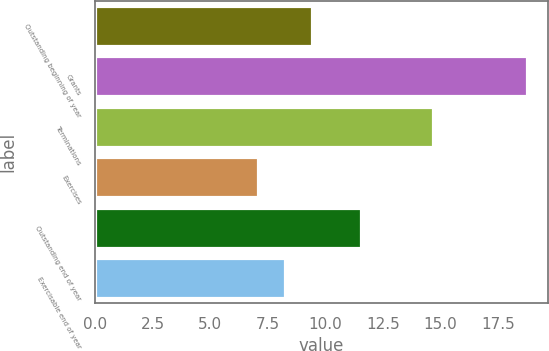<chart> <loc_0><loc_0><loc_500><loc_500><bar_chart><fcel>Outstanding beginning of year<fcel>Grants<fcel>Terminations<fcel>Exercises<fcel>Outstanding end of year<fcel>Exercisable end of year<nl><fcel>9.41<fcel>18.74<fcel>14.67<fcel>7.07<fcel>11.57<fcel>8.24<nl></chart> 